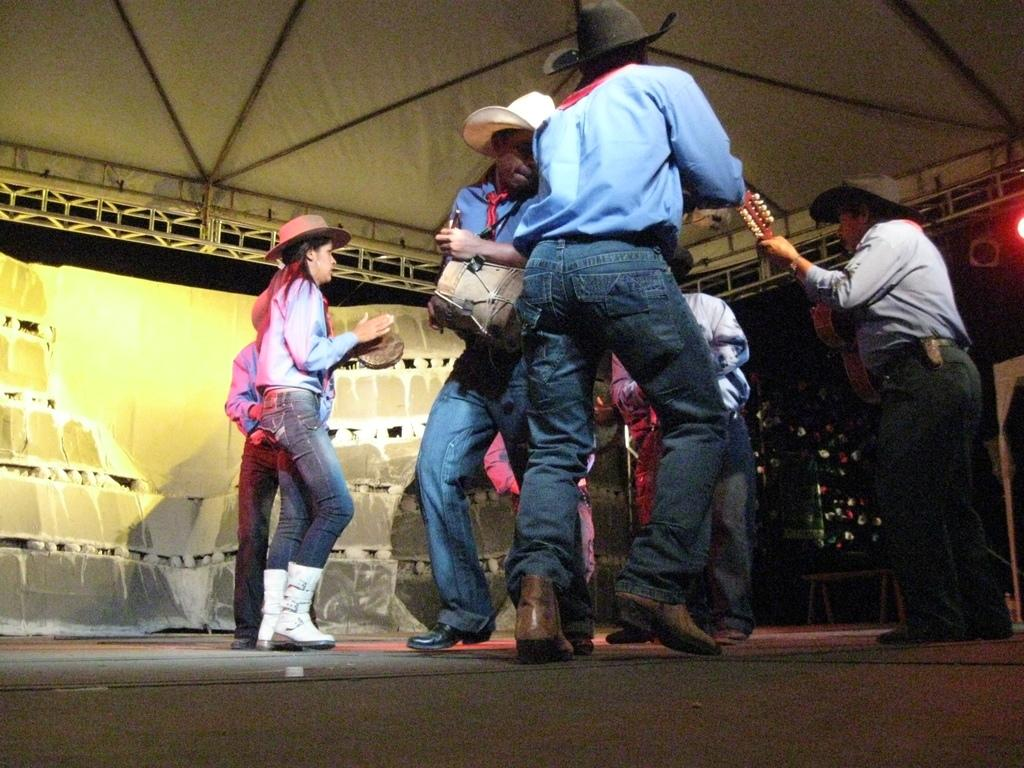Who is present in the image? There are people in the image. What type of clothing are the people wearing? The people are dressed like cowboys. What accessories are the people wearing? The people are wearing hats and boots. What activity are the people engaged in? The people are dancing on a stage. What can be seen above the stage in the image? There are lights over the ceiling in the image. How many eggs are being used as part of the cowboy dance performance in the image? There are no eggs present in the image; the people are dressed like cowboys and dancing on a stage. What type of wire is being used to hold up the zephyr in the image? There is no zephyr present in the image, and therefore no wire is being used to hold it up. 